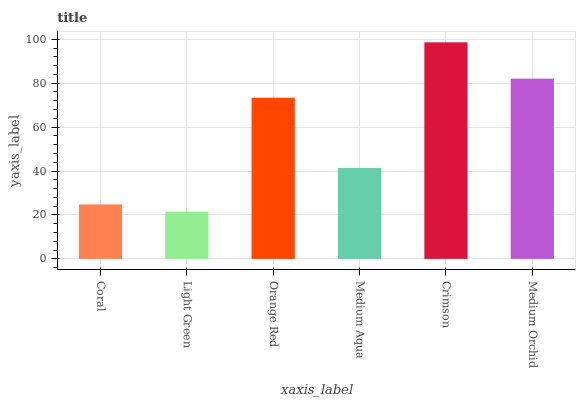Is Orange Red the minimum?
Answer yes or no. No. Is Orange Red the maximum?
Answer yes or no. No. Is Orange Red greater than Light Green?
Answer yes or no. Yes. Is Light Green less than Orange Red?
Answer yes or no. Yes. Is Light Green greater than Orange Red?
Answer yes or no. No. Is Orange Red less than Light Green?
Answer yes or no. No. Is Orange Red the high median?
Answer yes or no. Yes. Is Medium Aqua the low median?
Answer yes or no. Yes. Is Coral the high median?
Answer yes or no. No. Is Medium Orchid the low median?
Answer yes or no. No. 